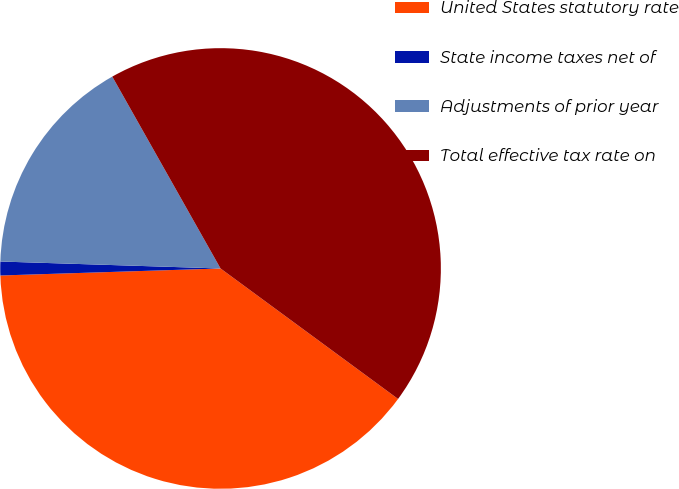Convert chart. <chart><loc_0><loc_0><loc_500><loc_500><pie_chart><fcel>United States statutory rate<fcel>State income taxes net of<fcel>Adjustments of prior year<fcel>Total effective tax rate on<nl><fcel>39.4%<fcel>1.01%<fcel>16.32%<fcel>43.26%<nl></chart> 